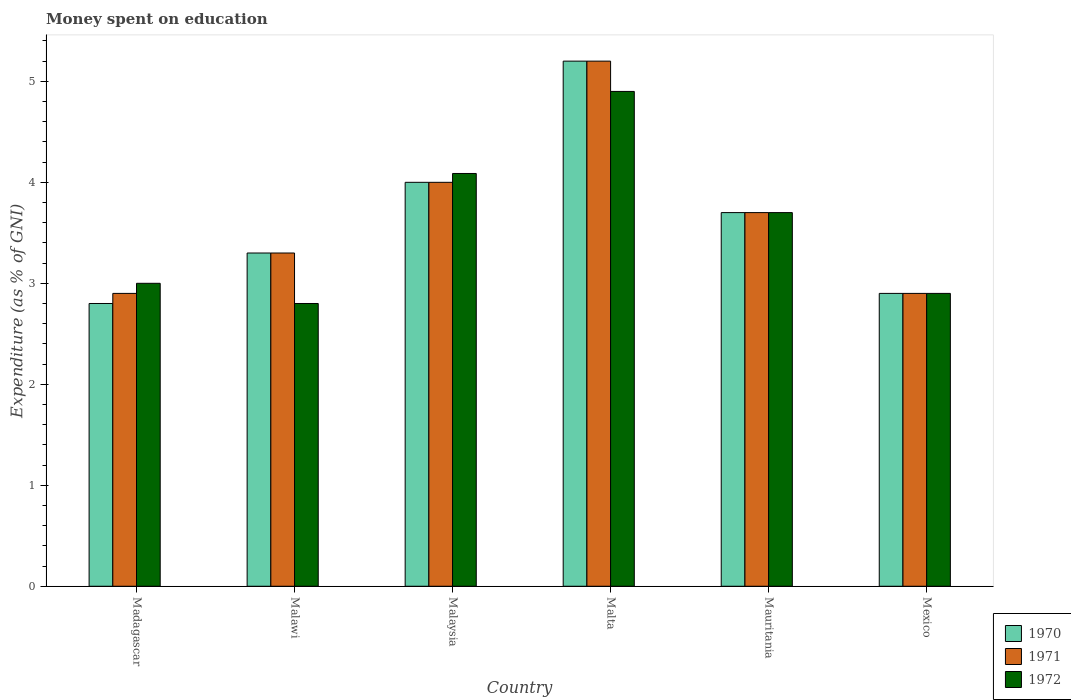How many different coloured bars are there?
Provide a succinct answer. 3. How many groups of bars are there?
Make the answer very short. 6. Are the number of bars per tick equal to the number of legend labels?
Make the answer very short. Yes. Are the number of bars on each tick of the X-axis equal?
Offer a terse response. Yes. How many bars are there on the 1st tick from the left?
Provide a succinct answer. 3. How many bars are there on the 1st tick from the right?
Your answer should be compact. 3. What is the label of the 3rd group of bars from the left?
Give a very brief answer. Malaysia. In how many cases, is the number of bars for a given country not equal to the number of legend labels?
Your response must be concise. 0. Across all countries, what is the maximum amount of money spent on education in 1970?
Provide a succinct answer. 5.2. In which country was the amount of money spent on education in 1972 maximum?
Ensure brevity in your answer.  Malta. In which country was the amount of money spent on education in 1971 minimum?
Provide a succinct answer. Madagascar. What is the total amount of money spent on education in 1971 in the graph?
Provide a succinct answer. 22. What is the difference between the amount of money spent on education in 1971 in Madagascar and that in Malawi?
Provide a succinct answer. -0.4. What is the difference between the amount of money spent on education in 1970 in Mauritania and the amount of money spent on education in 1972 in Mexico?
Your answer should be compact. 0.8. What is the average amount of money spent on education in 1970 per country?
Your answer should be compact. 3.65. What is the difference between the amount of money spent on education of/in 1970 and amount of money spent on education of/in 1971 in Madagascar?
Keep it short and to the point. -0.1. In how many countries, is the amount of money spent on education in 1972 greater than 2.6 %?
Provide a succinct answer. 6. What is the ratio of the amount of money spent on education in 1970 in Madagascar to that in Malta?
Provide a short and direct response. 0.54. Is the amount of money spent on education in 1972 in Malawi less than that in Mauritania?
Provide a succinct answer. Yes. What is the difference between the highest and the second highest amount of money spent on education in 1972?
Ensure brevity in your answer.  -1.2. What is the difference between the highest and the lowest amount of money spent on education in 1970?
Offer a terse response. 2.4. In how many countries, is the amount of money spent on education in 1971 greater than the average amount of money spent on education in 1971 taken over all countries?
Your answer should be compact. 3. What does the 2nd bar from the right in Madagascar represents?
Keep it short and to the point. 1971. Is it the case that in every country, the sum of the amount of money spent on education in 1972 and amount of money spent on education in 1970 is greater than the amount of money spent on education in 1971?
Offer a terse response. Yes. How many countries are there in the graph?
Your answer should be very brief. 6. What is the difference between two consecutive major ticks on the Y-axis?
Offer a very short reply. 1. Does the graph contain any zero values?
Your response must be concise. No. Does the graph contain grids?
Your answer should be very brief. No. Where does the legend appear in the graph?
Your answer should be very brief. Bottom right. How many legend labels are there?
Provide a succinct answer. 3. What is the title of the graph?
Provide a succinct answer. Money spent on education. What is the label or title of the Y-axis?
Make the answer very short. Expenditure (as % of GNI). What is the Expenditure (as % of GNI) in 1971 in Malawi?
Offer a very short reply. 3.3. What is the Expenditure (as % of GNI) in 1972 in Malaysia?
Keep it short and to the point. 4.09. What is the Expenditure (as % of GNI) in 1970 in Mauritania?
Make the answer very short. 3.7. What is the Expenditure (as % of GNI) in 1971 in Mauritania?
Your answer should be very brief. 3.7. What is the Expenditure (as % of GNI) in 1972 in Mauritania?
Provide a short and direct response. 3.7. What is the Expenditure (as % of GNI) of 1971 in Mexico?
Ensure brevity in your answer.  2.9. Across all countries, what is the maximum Expenditure (as % of GNI) in 1970?
Provide a succinct answer. 5.2. Across all countries, what is the maximum Expenditure (as % of GNI) in 1971?
Ensure brevity in your answer.  5.2. Across all countries, what is the minimum Expenditure (as % of GNI) of 1970?
Your answer should be compact. 2.8. Across all countries, what is the minimum Expenditure (as % of GNI) in 1971?
Your answer should be compact. 2.9. What is the total Expenditure (as % of GNI) in 1970 in the graph?
Your response must be concise. 21.9. What is the total Expenditure (as % of GNI) of 1971 in the graph?
Provide a short and direct response. 22. What is the total Expenditure (as % of GNI) of 1972 in the graph?
Offer a very short reply. 21.39. What is the difference between the Expenditure (as % of GNI) of 1970 in Madagascar and that in Malawi?
Make the answer very short. -0.5. What is the difference between the Expenditure (as % of GNI) of 1972 in Madagascar and that in Malawi?
Offer a terse response. 0.2. What is the difference between the Expenditure (as % of GNI) of 1970 in Madagascar and that in Malaysia?
Provide a short and direct response. -1.2. What is the difference between the Expenditure (as % of GNI) of 1972 in Madagascar and that in Malaysia?
Keep it short and to the point. -1.09. What is the difference between the Expenditure (as % of GNI) of 1972 in Madagascar and that in Malta?
Give a very brief answer. -1.9. What is the difference between the Expenditure (as % of GNI) in 1970 in Madagascar and that in Mauritania?
Provide a succinct answer. -0.9. What is the difference between the Expenditure (as % of GNI) in 1971 in Madagascar and that in Mauritania?
Give a very brief answer. -0.8. What is the difference between the Expenditure (as % of GNI) in 1972 in Madagascar and that in Mauritania?
Provide a succinct answer. -0.7. What is the difference between the Expenditure (as % of GNI) in 1970 in Madagascar and that in Mexico?
Your answer should be very brief. -0.1. What is the difference between the Expenditure (as % of GNI) in 1971 in Madagascar and that in Mexico?
Make the answer very short. 0. What is the difference between the Expenditure (as % of GNI) of 1970 in Malawi and that in Malaysia?
Make the answer very short. -0.7. What is the difference between the Expenditure (as % of GNI) in 1972 in Malawi and that in Malaysia?
Your answer should be compact. -1.29. What is the difference between the Expenditure (as % of GNI) of 1972 in Malawi and that in Malta?
Provide a short and direct response. -2.1. What is the difference between the Expenditure (as % of GNI) of 1971 in Malawi and that in Mauritania?
Give a very brief answer. -0.4. What is the difference between the Expenditure (as % of GNI) in 1972 in Malawi and that in Mexico?
Give a very brief answer. -0.1. What is the difference between the Expenditure (as % of GNI) in 1971 in Malaysia and that in Malta?
Your answer should be very brief. -1.2. What is the difference between the Expenditure (as % of GNI) in 1972 in Malaysia and that in Malta?
Provide a short and direct response. -0.81. What is the difference between the Expenditure (as % of GNI) in 1972 in Malaysia and that in Mauritania?
Give a very brief answer. 0.39. What is the difference between the Expenditure (as % of GNI) of 1972 in Malaysia and that in Mexico?
Give a very brief answer. 1.19. What is the difference between the Expenditure (as % of GNI) of 1971 in Malta and that in Mauritania?
Your response must be concise. 1.5. What is the difference between the Expenditure (as % of GNI) in 1972 in Malta and that in Mauritania?
Provide a succinct answer. 1.2. What is the difference between the Expenditure (as % of GNI) of 1972 in Mauritania and that in Mexico?
Make the answer very short. 0.8. What is the difference between the Expenditure (as % of GNI) of 1970 in Madagascar and the Expenditure (as % of GNI) of 1972 in Malawi?
Provide a short and direct response. 0. What is the difference between the Expenditure (as % of GNI) in 1970 in Madagascar and the Expenditure (as % of GNI) in 1971 in Malaysia?
Provide a succinct answer. -1.2. What is the difference between the Expenditure (as % of GNI) in 1970 in Madagascar and the Expenditure (as % of GNI) in 1972 in Malaysia?
Make the answer very short. -1.29. What is the difference between the Expenditure (as % of GNI) of 1971 in Madagascar and the Expenditure (as % of GNI) of 1972 in Malaysia?
Offer a terse response. -1.19. What is the difference between the Expenditure (as % of GNI) of 1970 in Madagascar and the Expenditure (as % of GNI) of 1971 in Malta?
Provide a succinct answer. -2.4. What is the difference between the Expenditure (as % of GNI) in 1970 in Madagascar and the Expenditure (as % of GNI) in 1972 in Malta?
Ensure brevity in your answer.  -2.1. What is the difference between the Expenditure (as % of GNI) in 1971 in Madagascar and the Expenditure (as % of GNI) in 1972 in Malta?
Offer a very short reply. -2. What is the difference between the Expenditure (as % of GNI) in 1970 in Madagascar and the Expenditure (as % of GNI) in 1971 in Mexico?
Offer a very short reply. -0.1. What is the difference between the Expenditure (as % of GNI) in 1970 in Madagascar and the Expenditure (as % of GNI) in 1972 in Mexico?
Make the answer very short. -0.1. What is the difference between the Expenditure (as % of GNI) in 1970 in Malawi and the Expenditure (as % of GNI) in 1971 in Malaysia?
Give a very brief answer. -0.7. What is the difference between the Expenditure (as % of GNI) of 1970 in Malawi and the Expenditure (as % of GNI) of 1972 in Malaysia?
Give a very brief answer. -0.79. What is the difference between the Expenditure (as % of GNI) in 1971 in Malawi and the Expenditure (as % of GNI) in 1972 in Malaysia?
Provide a succinct answer. -0.79. What is the difference between the Expenditure (as % of GNI) of 1970 in Malawi and the Expenditure (as % of GNI) of 1972 in Malta?
Offer a very short reply. -1.6. What is the difference between the Expenditure (as % of GNI) of 1971 in Malawi and the Expenditure (as % of GNI) of 1972 in Mauritania?
Keep it short and to the point. -0.4. What is the difference between the Expenditure (as % of GNI) in 1970 in Malawi and the Expenditure (as % of GNI) in 1972 in Mexico?
Ensure brevity in your answer.  0.4. What is the difference between the Expenditure (as % of GNI) in 1971 in Malawi and the Expenditure (as % of GNI) in 1972 in Mexico?
Your answer should be very brief. 0.4. What is the difference between the Expenditure (as % of GNI) of 1970 in Malaysia and the Expenditure (as % of GNI) of 1971 in Malta?
Your answer should be very brief. -1.2. What is the difference between the Expenditure (as % of GNI) in 1970 in Malaysia and the Expenditure (as % of GNI) in 1972 in Malta?
Make the answer very short. -0.9. What is the difference between the Expenditure (as % of GNI) of 1970 in Malaysia and the Expenditure (as % of GNI) of 1971 in Mexico?
Provide a short and direct response. 1.1. What is the difference between the Expenditure (as % of GNI) in 1970 in Malaysia and the Expenditure (as % of GNI) in 1972 in Mexico?
Provide a short and direct response. 1.1. What is the difference between the Expenditure (as % of GNI) in 1971 in Malta and the Expenditure (as % of GNI) in 1972 in Mauritania?
Your response must be concise. 1.5. What is the difference between the Expenditure (as % of GNI) of 1970 in Mauritania and the Expenditure (as % of GNI) of 1971 in Mexico?
Your response must be concise. 0.8. What is the difference between the Expenditure (as % of GNI) of 1970 in Mauritania and the Expenditure (as % of GNI) of 1972 in Mexico?
Provide a succinct answer. 0.8. What is the difference between the Expenditure (as % of GNI) of 1971 in Mauritania and the Expenditure (as % of GNI) of 1972 in Mexico?
Offer a terse response. 0.8. What is the average Expenditure (as % of GNI) in 1970 per country?
Your answer should be very brief. 3.65. What is the average Expenditure (as % of GNI) in 1971 per country?
Your answer should be compact. 3.67. What is the average Expenditure (as % of GNI) of 1972 per country?
Provide a succinct answer. 3.56. What is the difference between the Expenditure (as % of GNI) in 1970 and Expenditure (as % of GNI) in 1972 in Madagascar?
Provide a succinct answer. -0.2. What is the difference between the Expenditure (as % of GNI) of 1971 and Expenditure (as % of GNI) of 1972 in Madagascar?
Offer a very short reply. -0.1. What is the difference between the Expenditure (as % of GNI) in 1970 and Expenditure (as % of GNI) in 1971 in Malawi?
Make the answer very short. 0. What is the difference between the Expenditure (as % of GNI) of 1970 and Expenditure (as % of GNI) of 1971 in Malaysia?
Provide a succinct answer. 0. What is the difference between the Expenditure (as % of GNI) in 1970 and Expenditure (as % of GNI) in 1972 in Malaysia?
Offer a terse response. -0.09. What is the difference between the Expenditure (as % of GNI) of 1971 and Expenditure (as % of GNI) of 1972 in Malaysia?
Provide a succinct answer. -0.09. What is the difference between the Expenditure (as % of GNI) in 1970 and Expenditure (as % of GNI) in 1972 in Malta?
Offer a very short reply. 0.3. What is the difference between the Expenditure (as % of GNI) of 1970 and Expenditure (as % of GNI) of 1971 in Mexico?
Keep it short and to the point. 0. What is the difference between the Expenditure (as % of GNI) in 1971 and Expenditure (as % of GNI) in 1972 in Mexico?
Ensure brevity in your answer.  0. What is the ratio of the Expenditure (as % of GNI) of 1970 in Madagascar to that in Malawi?
Ensure brevity in your answer.  0.85. What is the ratio of the Expenditure (as % of GNI) in 1971 in Madagascar to that in Malawi?
Make the answer very short. 0.88. What is the ratio of the Expenditure (as % of GNI) in 1972 in Madagascar to that in Malawi?
Offer a very short reply. 1.07. What is the ratio of the Expenditure (as % of GNI) of 1971 in Madagascar to that in Malaysia?
Provide a succinct answer. 0.72. What is the ratio of the Expenditure (as % of GNI) in 1972 in Madagascar to that in Malaysia?
Your answer should be very brief. 0.73. What is the ratio of the Expenditure (as % of GNI) in 1970 in Madagascar to that in Malta?
Give a very brief answer. 0.54. What is the ratio of the Expenditure (as % of GNI) of 1971 in Madagascar to that in Malta?
Your answer should be very brief. 0.56. What is the ratio of the Expenditure (as % of GNI) of 1972 in Madagascar to that in Malta?
Provide a short and direct response. 0.61. What is the ratio of the Expenditure (as % of GNI) in 1970 in Madagascar to that in Mauritania?
Give a very brief answer. 0.76. What is the ratio of the Expenditure (as % of GNI) of 1971 in Madagascar to that in Mauritania?
Your answer should be very brief. 0.78. What is the ratio of the Expenditure (as % of GNI) in 1972 in Madagascar to that in Mauritania?
Offer a terse response. 0.81. What is the ratio of the Expenditure (as % of GNI) in 1970 in Madagascar to that in Mexico?
Offer a terse response. 0.97. What is the ratio of the Expenditure (as % of GNI) of 1972 in Madagascar to that in Mexico?
Your answer should be very brief. 1.03. What is the ratio of the Expenditure (as % of GNI) of 1970 in Malawi to that in Malaysia?
Give a very brief answer. 0.82. What is the ratio of the Expenditure (as % of GNI) in 1971 in Malawi to that in Malaysia?
Make the answer very short. 0.82. What is the ratio of the Expenditure (as % of GNI) of 1972 in Malawi to that in Malaysia?
Your response must be concise. 0.69. What is the ratio of the Expenditure (as % of GNI) in 1970 in Malawi to that in Malta?
Ensure brevity in your answer.  0.63. What is the ratio of the Expenditure (as % of GNI) in 1971 in Malawi to that in Malta?
Your answer should be compact. 0.63. What is the ratio of the Expenditure (as % of GNI) of 1970 in Malawi to that in Mauritania?
Your response must be concise. 0.89. What is the ratio of the Expenditure (as % of GNI) of 1971 in Malawi to that in Mauritania?
Offer a terse response. 0.89. What is the ratio of the Expenditure (as % of GNI) in 1972 in Malawi to that in Mauritania?
Keep it short and to the point. 0.76. What is the ratio of the Expenditure (as % of GNI) of 1970 in Malawi to that in Mexico?
Provide a short and direct response. 1.14. What is the ratio of the Expenditure (as % of GNI) in 1971 in Malawi to that in Mexico?
Provide a short and direct response. 1.14. What is the ratio of the Expenditure (as % of GNI) of 1972 in Malawi to that in Mexico?
Give a very brief answer. 0.97. What is the ratio of the Expenditure (as % of GNI) of 1970 in Malaysia to that in Malta?
Your response must be concise. 0.77. What is the ratio of the Expenditure (as % of GNI) in 1971 in Malaysia to that in Malta?
Your answer should be compact. 0.77. What is the ratio of the Expenditure (as % of GNI) of 1972 in Malaysia to that in Malta?
Keep it short and to the point. 0.83. What is the ratio of the Expenditure (as % of GNI) of 1970 in Malaysia to that in Mauritania?
Make the answer very short. 1.08. What is the ratio of the Expenditure (as % of GNI) of 1971 in Malaysia to that in Mauritania?
Give a very brief answer. 1.08. What is the ratio of the Expenditure (as % of GNI) of 1972 in Malaysia to that in Mauritania?
Offer a terse response. 1.1. What is the ratio of the Expenditure (as % of GNI) in 1970 in Malaysia to that in Mexico?
Provide a succinct answer. 1.38. What is the ratio of the Expenditure (as % of GNI) of 1971 in Malaysia to that in Mexico?
Provide a short and direct response. 1.38. What is the ratio of the Expenditure (as % of GNI) in 1972 in Malaysia to that in Mexico?
Provide a short and direct response. 1.41. What is the ratio of the Expenditure (as % of GNI) of 1970 in Malta to that in Mauritania?
Your response must be concise. 1.41. What is the ratio of the Expenditure (as % of GNI) in 1971 in Malta to that in Mauritania?
Ensure brevity in your answer.  1.41. What is the ratio of the Expenditure (as % of GNI) in 1972 in Malta to that in Mauritania?
Your answer should be compact. 1.32. What is the ratio of the Expenditure (as % of GNI) of 1970 in Malta to that in Mexico?
Keep it short and to the point. 1.79. What is the ratio of the Expenditure (as % of GNI) of 1971 in Malta to that in Mexico?
Your response must be concise. 1.79. What is the ratio of the Expenditure (as % of GNI) in 1972 in Malta to that in Mexico?
Offer a very short reply. 1.69. What is the ratio of the Expenditure (as % of GNI) in 1970 in Mauritania to that in Mexico?
Ensure brevity in your answer.  1.28. What is the ratio of the Expenditure (as % of GNI) in 1971 in Mauritania to that in Mexico?
Your answer should be very brief. 1.28. What is the ratio of the Expenditure (as % of GNI) of 1972 in Mauritania to that in Mexico?
Provide a short and direct response. 1.28. What is the difference between the highest and the second highest Expenditure (as % of GNI) in 1971?
Make the answer very short. 1.2. What is the difference between the highest and the second highest Expenditure (as % of GNI) of 1972?
Ensure brevity in your answer.  0.81. 